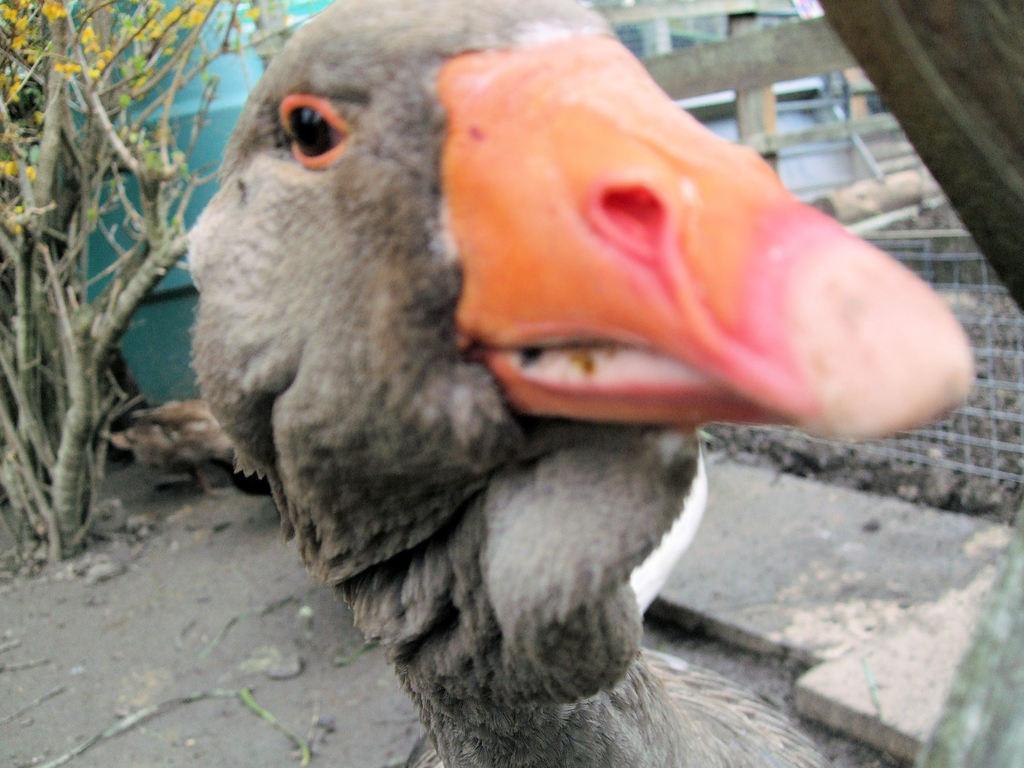Could you give a brief overview of what you see in this image? In this image I can see a grey colour bird in the front. In the background I can see a plant, few wooden poles and fencing. I can also see number of sticks on the ground. 